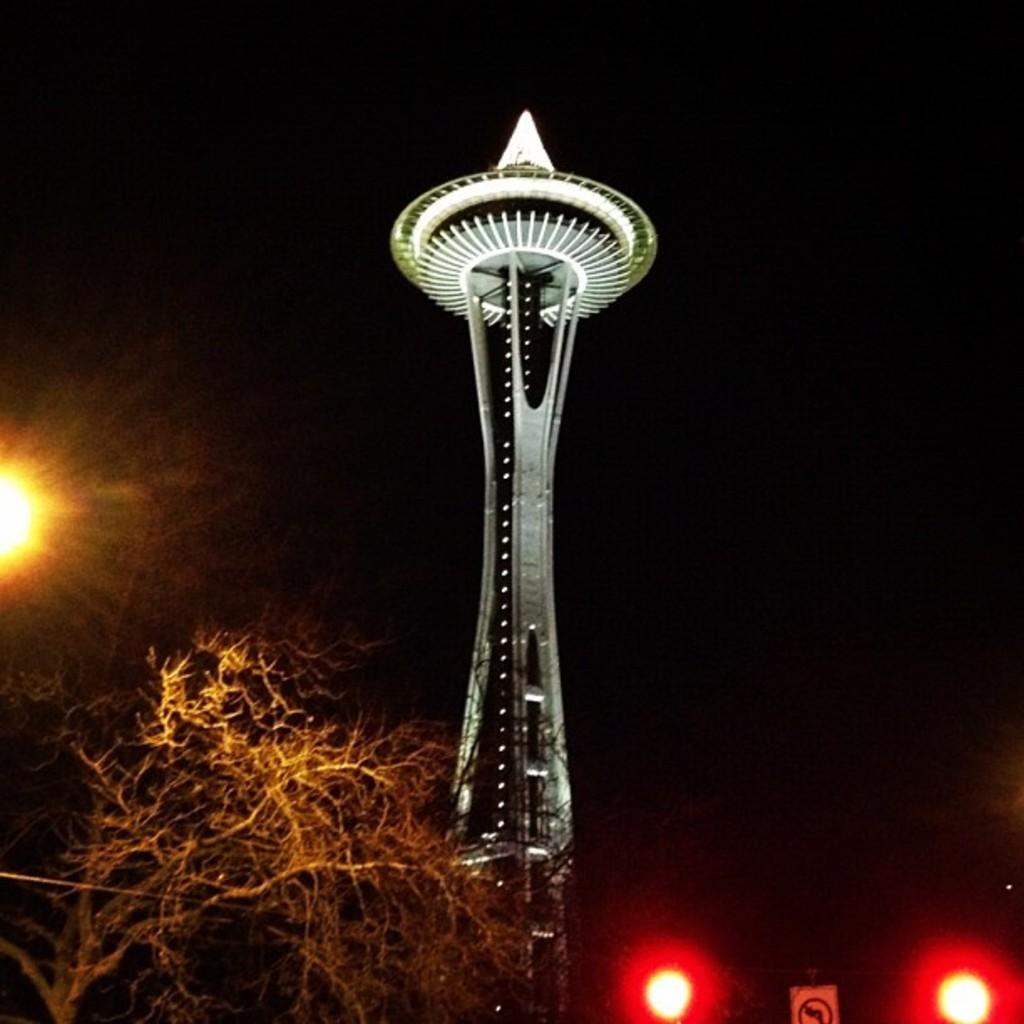Describe this image in one or two sentences. In this image we can see an object like tower and a tree is there. 